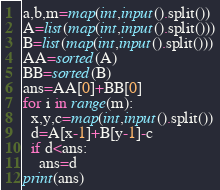<code> <loc_0><loc_0><loc_500><loc_500><_Python_>a,b,m=map(int,input().split())
A=list(map(int,input().split()))
B=list(map(int,input().split()))
AA=sorted(A)
BB=sorted(B)
ans=AA[0]+BB[0]
for i in range(m):
  x,y,c=map(int,input().split())
  d=A[x-1]+B[y-1]-c
  if d<ans:
    ans=d
print(ans)</code> 